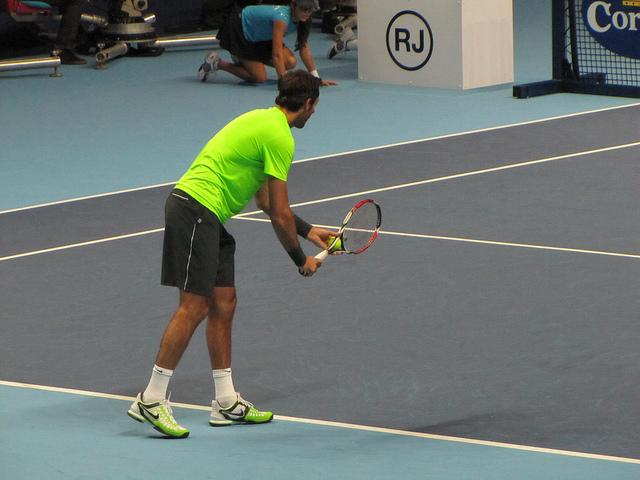What is the job of the girl who is knelt down in the front of the picture?

Choices:
A) collect ball
B) spectator
C) referee
D) camera crew collect ball 